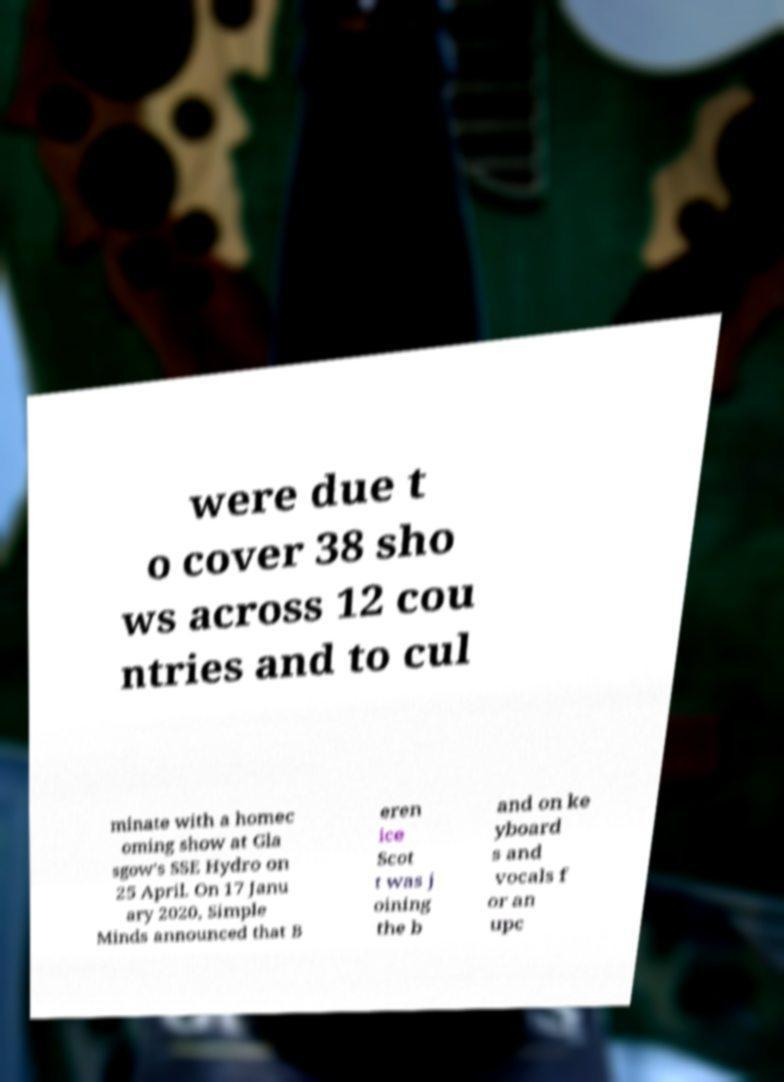Can you accurately transcribe the text from the provided image for me? were due t o cover 38 sho ws across 12 cou ntries and to cul minate with a homec oming show at Gla sgow's SSE Hydro on 25 April. On 17 Janu ary 2020, Simple Minds announced that B eren ice Scot t was j oining the b and on ke yboard s and vocals f or an upc 